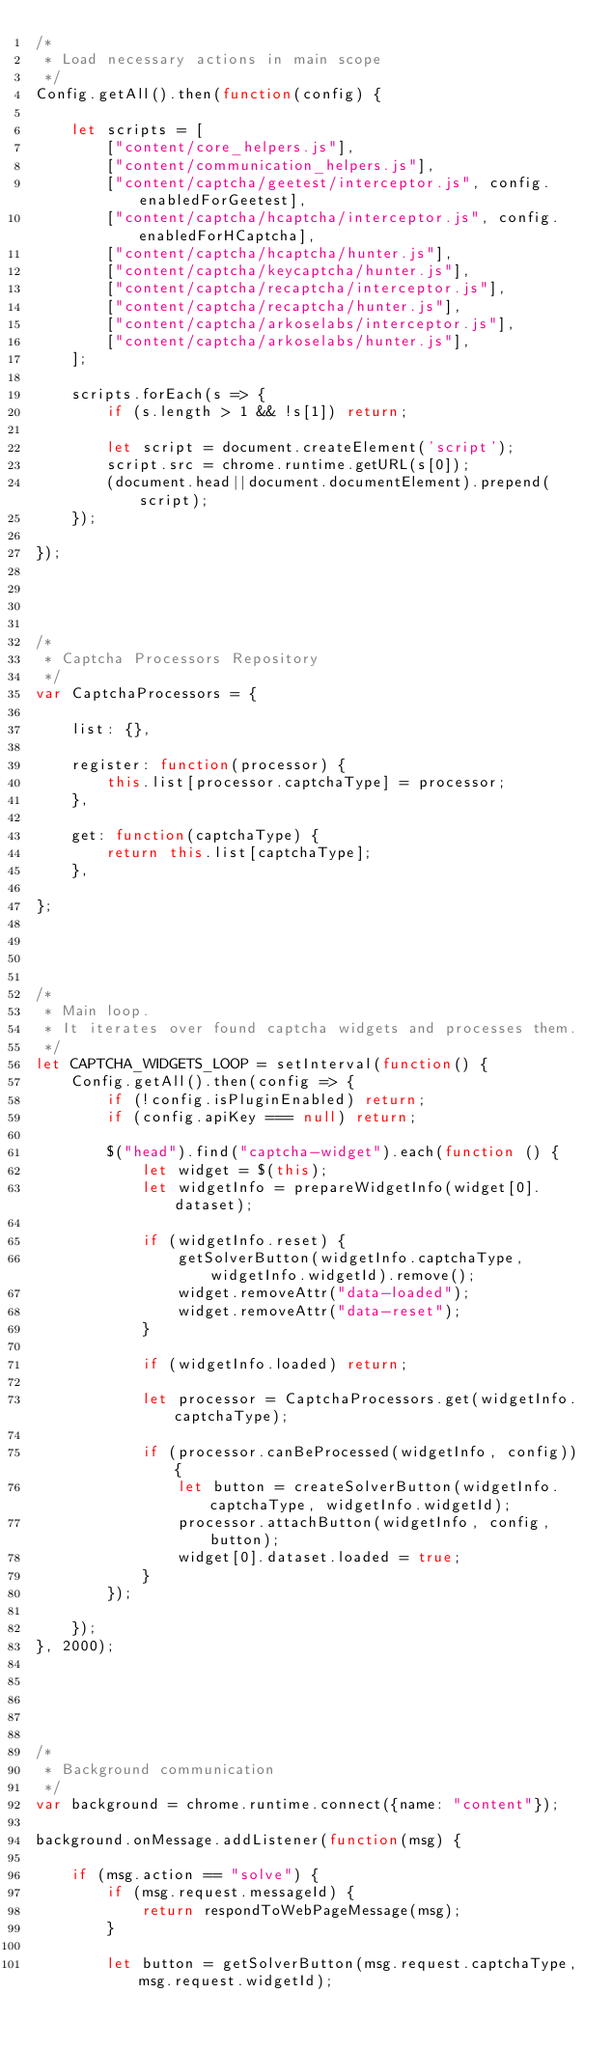Convert code to text. <code><loc_0><loc_0><loc_500><loc_500><_JavaScript_>/*
 * Load necessary actions in main scope
 */
Config.getAll().then(function(config) {

    let scripts = [
        ["content/core_helpers.js"],
        ["content/communication_helpers.js"],
        ["content/captcha/geetest/interceptor.js", config.enabledForGeetest],
        ["content/captcha/hcaptcha/interceptor.js", config.enabledForHCaptcha],
        ["content/captcha/hcaptcha/hunter.js"],
        ["content/captcha/keycaptcha/hunter.js"],
        ["content/captcha/recaptcha/interceptor.js"],
        ["content/captcha/recaptcha/hunter.js"],
        ["content/captcha/arkoselabs/interceptor.js"],
        ["content/captcha/arkoselabs/hunter.js"],
    ];

    scripts.forEach(s => {
        if (s.length > 1 && !s[1]) return;

        let script = document.createElement('script');
        script.src = chrome.runtime.getURL(s[0]);
        (document.head||document.documentElement).prepend(script);
    });

});




/*
 * Captcha Processors Repository
 */
var CaptchaProcessors = {

    list: {},

    register: function(processor) {
        this.list[processor.captchaType] = processor;
    },

    get: function(captchaType) {
        return this.list[captchaType];
    },

};




/*
 * Main loop.
 * It iterates over found captcha widgets and processes them.
 */
let CAPTCHA_WIDGETS_LOOP = setInterval(function() {
    Config.getAll().then(config => {
        if (!config.isPluginEnabled) return;
        if (config.apiKey === null) return;

        $("head").find("captcha-widget").each(function () {
            let widget = $(this);
            let widgetInfo = prepareWidgetInfo(widget[0].dataset);

            if (widgetInfo.reset) {
                getSolverButton(widgetInfo.captchaType, widgetInfo.widgetId).remove();
                widget.removeAttr("data-loaded");
                widget.removeAttr("data-reset");
            }

            if (widgetInfo.loaded) return;

            let processor = CaptchaProcessors.get(widgetInfo.captchaType);

            if (processor.canBeProcessed(widgetInfo, config)) {
                let button = createSolverButton(widgetInfo.captchaType, widgetInfo.widgetId);
                processor.attachButton(widgetInfo, config, button);
                widget[0].dataset.loaded = true;
            }
        });

    });
}, 2000);





/*
 * Background communication
 */
var background = chrome.runtime.connect({name: "content"});

background.onMessage.addListener(function(msg) {

    if (msg.action == "solve") {
        if (msg.request.messageId) {
            return respondToWebPageMessage(msg);
        }

        let button = getSolverButton(msg.request.captchaType, msg.request.widgetId);
</code> 